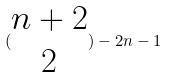Convert formula to latex. <formula><loc_0><loc_0><loc_500><loc_500>( \begin{matrix} n + 2 \\ 2 \end{matrix} ) - 2 n - 1</formula> 